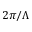Convert formula to latex. <formula><loc_0><loc_0><loc_500><loc_500>2 \pi / \Lambda</formula> 